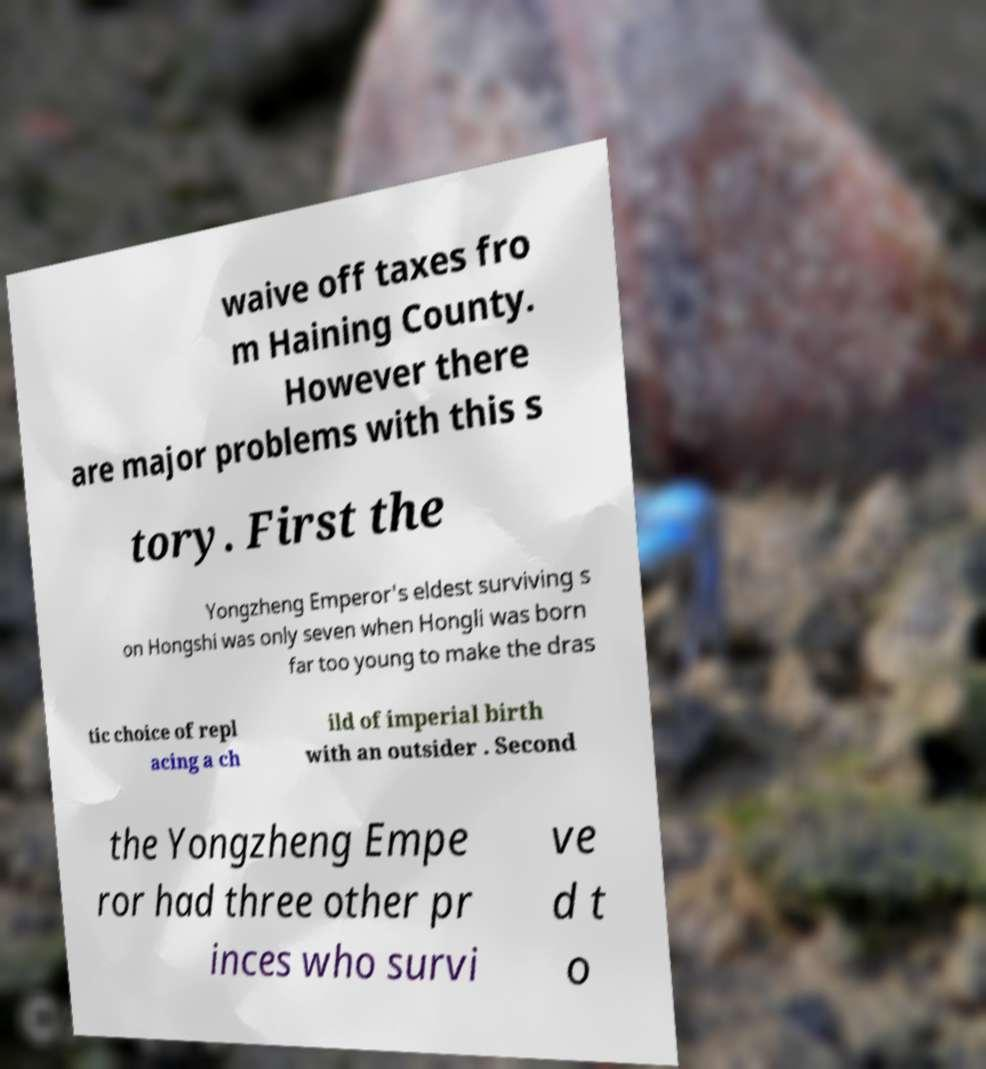For documentation purposes, I need the text within this image transcribed. Could you provide that? waive off taxes fro m Haining County. However there are major problems with this s tory. First the Yongzheng Emperor's eldest surviving s on Hongshi was only seven when Hongli was born far too young to make the dras tic choice of repl acing a ch ild of imperial birth with an outsider . Second the Yongzheng Empe ror had three other pr inces who survi ve d t o 